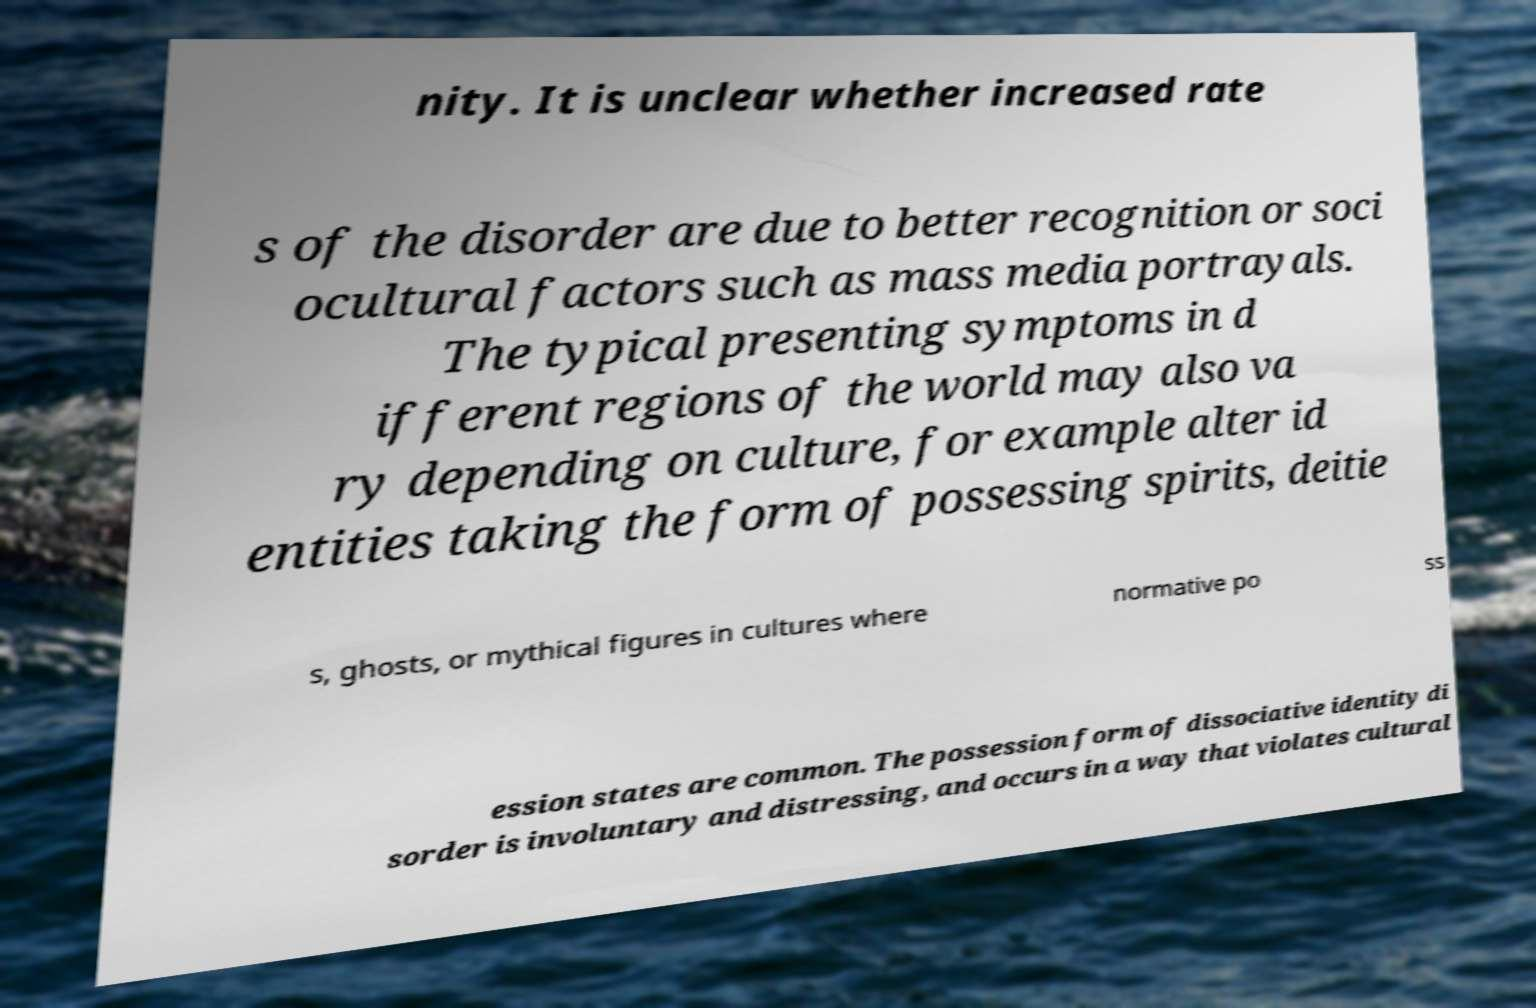What messages or text are displayed in this image? I need them in a readable, typed format. nity. It is unclear whether increased rate s of the disorder are due to better recognition or soci ocultural factors such as mass media portrayals. The typical presenting symptoms in d ifferent regions of the world may also va ry depending on culture, for example alter id entities taking the form of possessing spirits, deitie s, ghosts, or mythical figures in cultures where normative po ss ession states are common. The possession form of dissociative identity di sorder is involuntary and distressing, and occurs in a way that violates cultural 